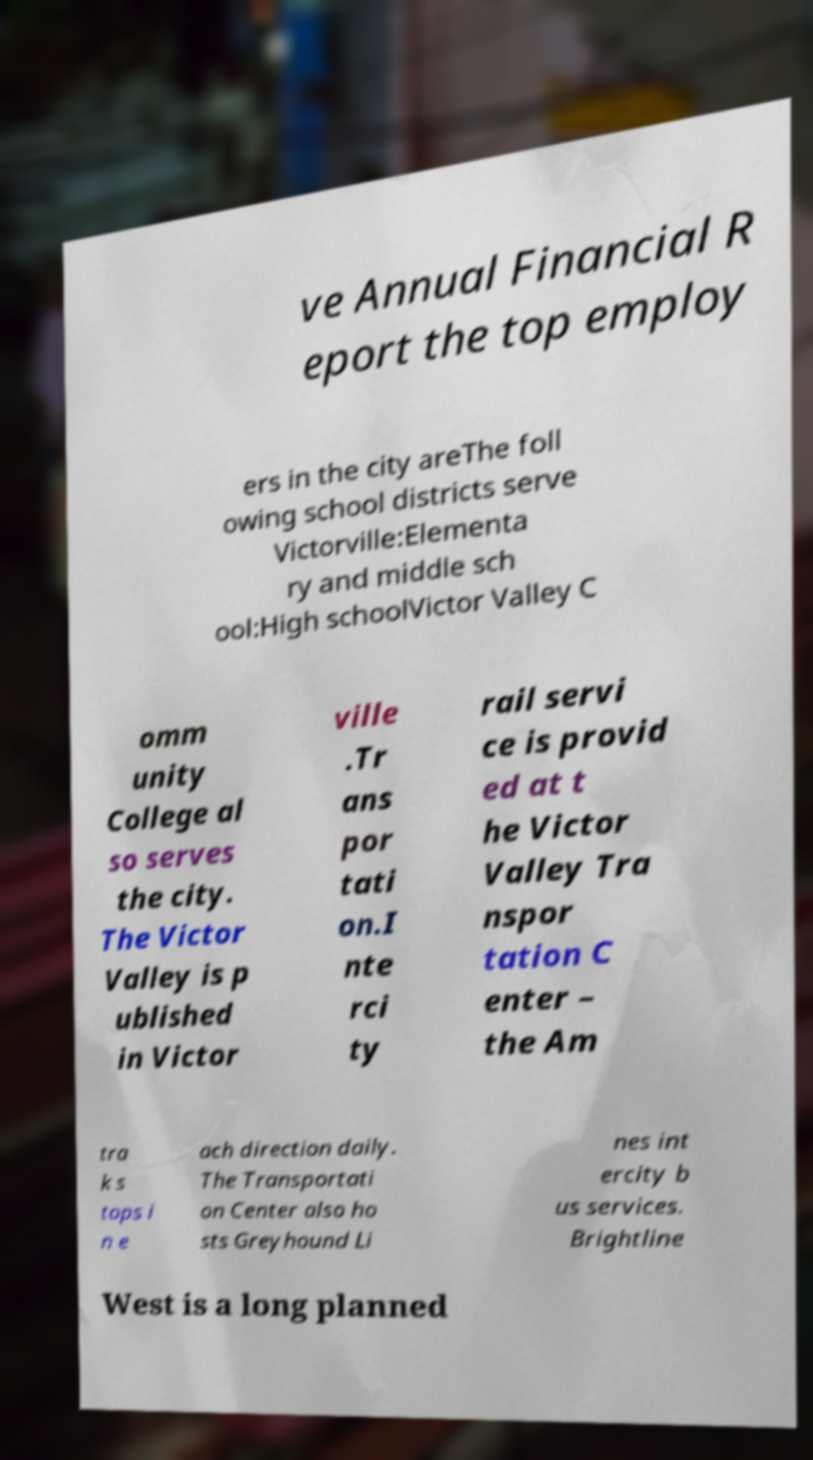Can you read and provide the text displayed in the image?This photo seems to have some interesting text. Can you extract and type it out for me? ve Annual Financial R eport the top employ ers in the city areThe foll owing school districts serve Victorville:Elementa ry and middle sch ool:High schoolVictor Valley C omm unity College al so serves the city. The Victor Valley is p ublished in Victor ville .Tr ans por tati on.I nte rci ty rail servi ce is provid ed at t he Victor Valley Tra nspor tation C enter – the Am tra k s tops i n e ach direction daily. The Transportati on Center also ho sts Greyhound Li nes int ercity b us services. Brightline West is a long planned 